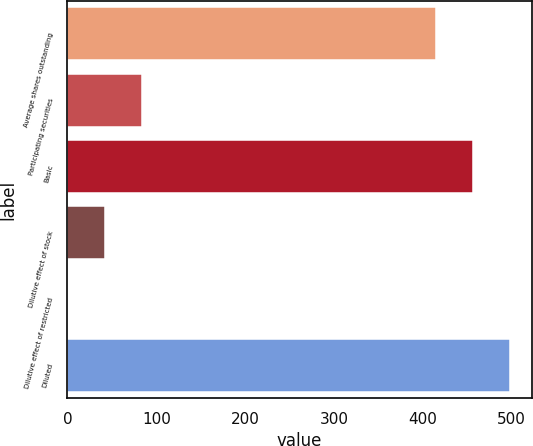Convert chart to OTSL. <chart><loc_0><loc_0><loc_500><loc_500><bar_chart><fcel>Average shares outstanding<fcel>Participating securities<fcel>Basic<fcel>Dilutive effect of stock<fcel>Dilutive effect of restricted<fcel>Diluted<nl><fcel>414.6<fcel>83.6<fcel>456.25<fcel>41.95<fcel>0.3<fcel>497.9<nl></chart> 